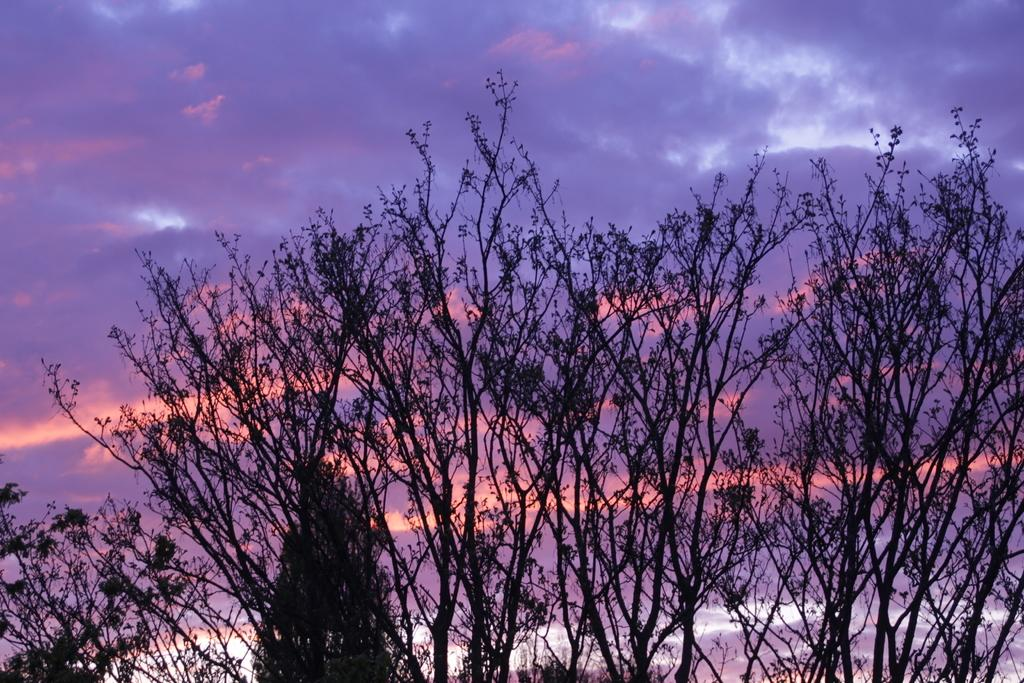What type of natural elements can be seen in the image? There are many trees in the image. What is visible in the sky in the image? There are clouds in the sky. What type of cord is being used to tie the zebra in the image? There is no zebra or cord present in the image; it features trees and clouds. Who is the creator of the trees in the image? The creator of the trees in the image cannot be determined from the image itself, as it is a natural occurrence. 